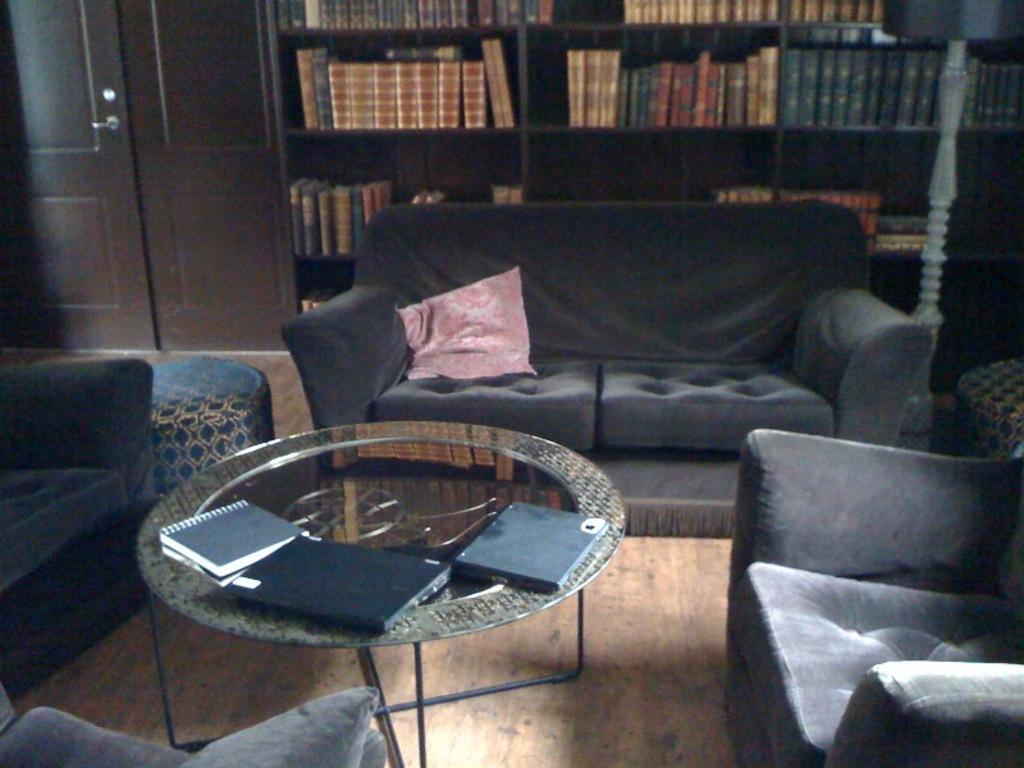How would you summarize this image in a sentence or two? In this image, we can see sofa, cushion, table, few items are there , floor. And the background, there is a big shelf ,books are filled. And right side, we can see lamp. Left side, there is a door. 